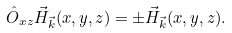<formula> <loc_0><loc_0><loc_500><loc_500>\hat { O } _ { x z } \vec { H } _ { \vec { k } } ( x , y , z ) = \pm \vec { H } _ { \vec { k } } ( x , y , z ) .</formula> 